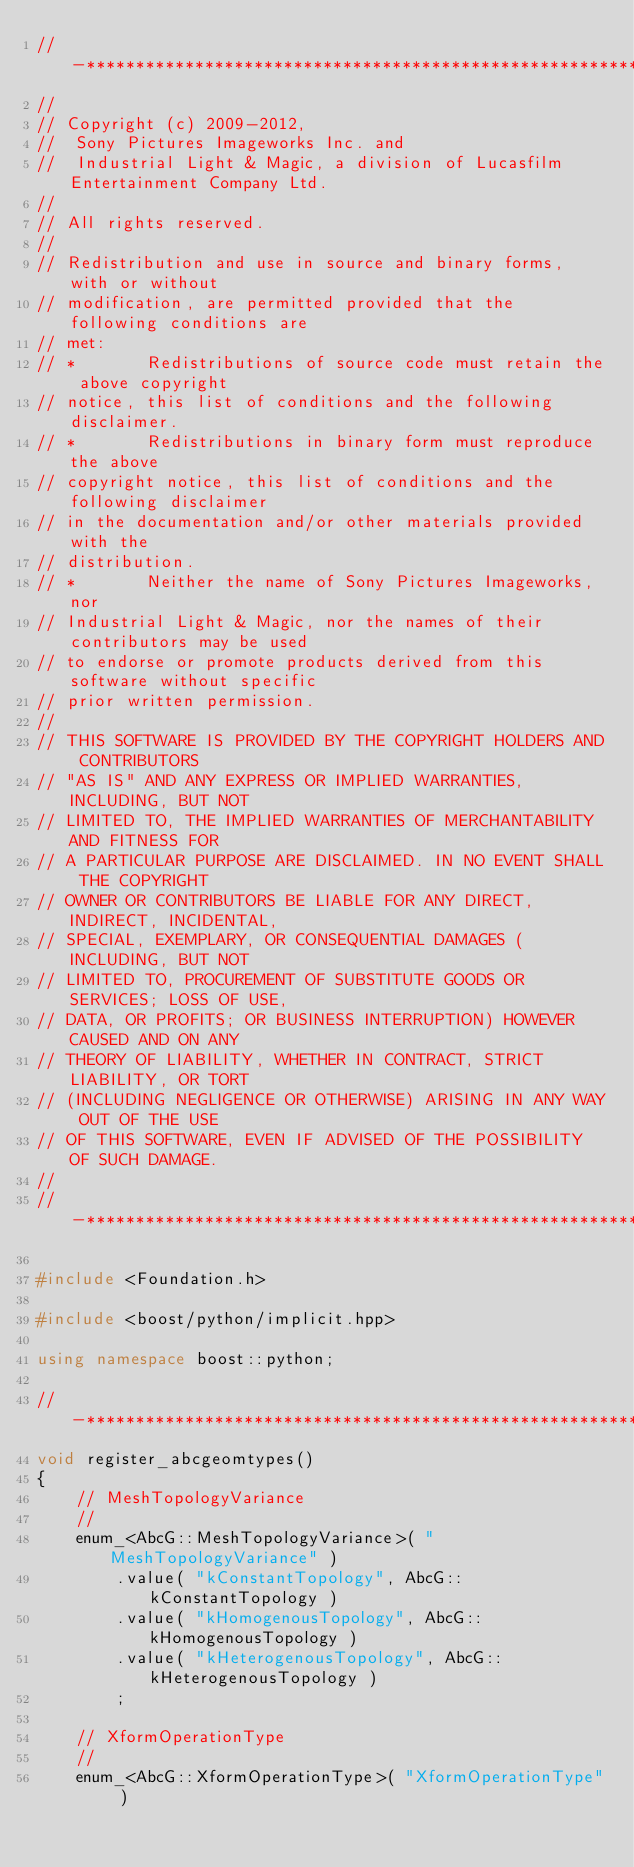Convert code to text. <code><loc_0><loc_0><loc_500><loc_500><_C++_>//-*****************************************************************************
//
// Copyright (c) 2009-2012,
//  Sony Pictures Imageworks Inc. and
//  Industrial Light & Magic, a division of Lucasfilm Entertainment Company Ltd.
//
// All rights reserved.
//
// Redistribution and use in source and binary forms, with or without
// modification, are permitted provided that the following conditions are
// met:
// *       Redistributions of source code must retain the above copyright
// notice, this list of conditions and the following disclaimer.
// *       Redistributions in binary form must reproduce the above
// copyright notice, this list of conditions and the following disclaimer
// in the documentation and/or other materials provided with the
// distribution.
// *       Neither the name of Sony Pictures Imageworks, nor
// Industrial Light & Magic, nor the names of their contributors may be used
// to endorse or promote products derived from this software without specific
// prior written permission.
//
// THIS SOFTWARE IS PROVIDED BY THE COPYRIGHT HOLDERS AND CONTRIBUTORS
// "AS IS" AND ANY EXPRESS OR IMPLIED WARRANTIES, INCLUDING, BUT NOT
// LIMITED TO, THE IMPLIED WARRANTIES OF MERCHANTABILITY AND FITNESS FOR
// A PARTICULAR PURPOSE ARE DISCLAIMED. IN NO EVENT SHALL THE COPYRIGHT
// OWNER OR CONTRIBUTORS BE LIABLE FOR ANY DIRECT, INDIRECT, INCIDENTAL,
// SPECIAL, EXEMPLARY, OR CONSEQUENTIAL DAMAGES (INCLUDING, BUT NOT
// LIMITED TO, PROCUREMENT OF SUBSTITUTE GOODS OR SERVICES; LOSS OF USE,
// DATA, OR PROFITS; OR BUSINESS INTERRUPTION) HOWEVER CAUSED AND ON ANY
// THEORY OF LIABILITY, WHETHER IN CONTRACT, STRICT LIABILITY, OR TORT
// (INCLUDING NEGLIGENCE OR OTHERWISE) ARISING IN ANY WAY OUT OF THE USE
// OF THIS SOFTWARE, EVEN IF ADVISED OF THE POSSIBILITY OF SUCH DAMAGE.
//
//-*****************************************************************************

#include <Foundation.h>

#include <boost/python/implicit.hpp>

using namespace boost::python;

//-*****************************************************************************
void register_abcgeomtypes()
{
    // MeshTopologyVariance
    //
    enum_<AbcG::MeshTopologyVariance>( "MeshTopologyVariance" )
        .value( "kConstantTopology", AbcG::kConstantTopology )
        .value( "kHomogenousTopology", AbcG::kHomogenousTopology )
        .value( "kHeterogenousTopology", AbcG::kHeterogenousTopology )
        ;

    // XformOperationType
    //
    enum_<AbcG::XformOperationType>( "XformOperationType" )</code> 